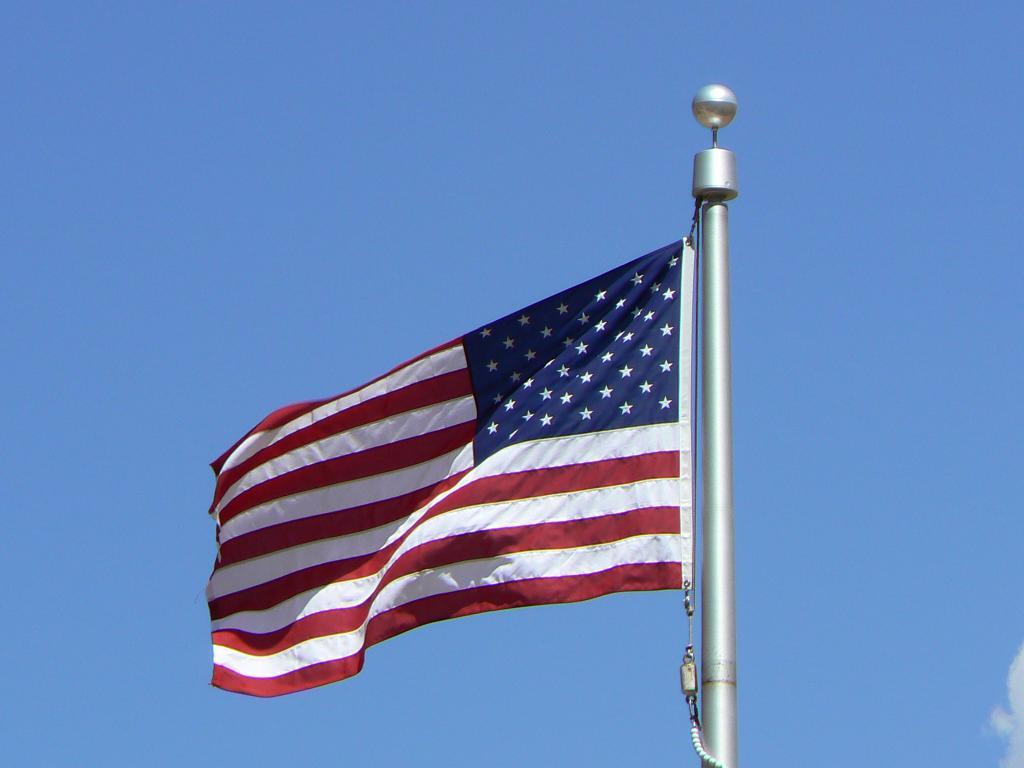What is the main object in the image? There is a flag in the image. How is the flag positioned in the image? The flag is on a pole. What colors are present on the flag? The flag has red, white, and blue colors. What can be seen in the background of the image? There is a blue sky in the background of the image. Can you see a cat pointing at the flag in the image? There is no cat or any indication of pointing in the image; it only features a flag on a pole with red, white, and blue colors against a blue sky background. 